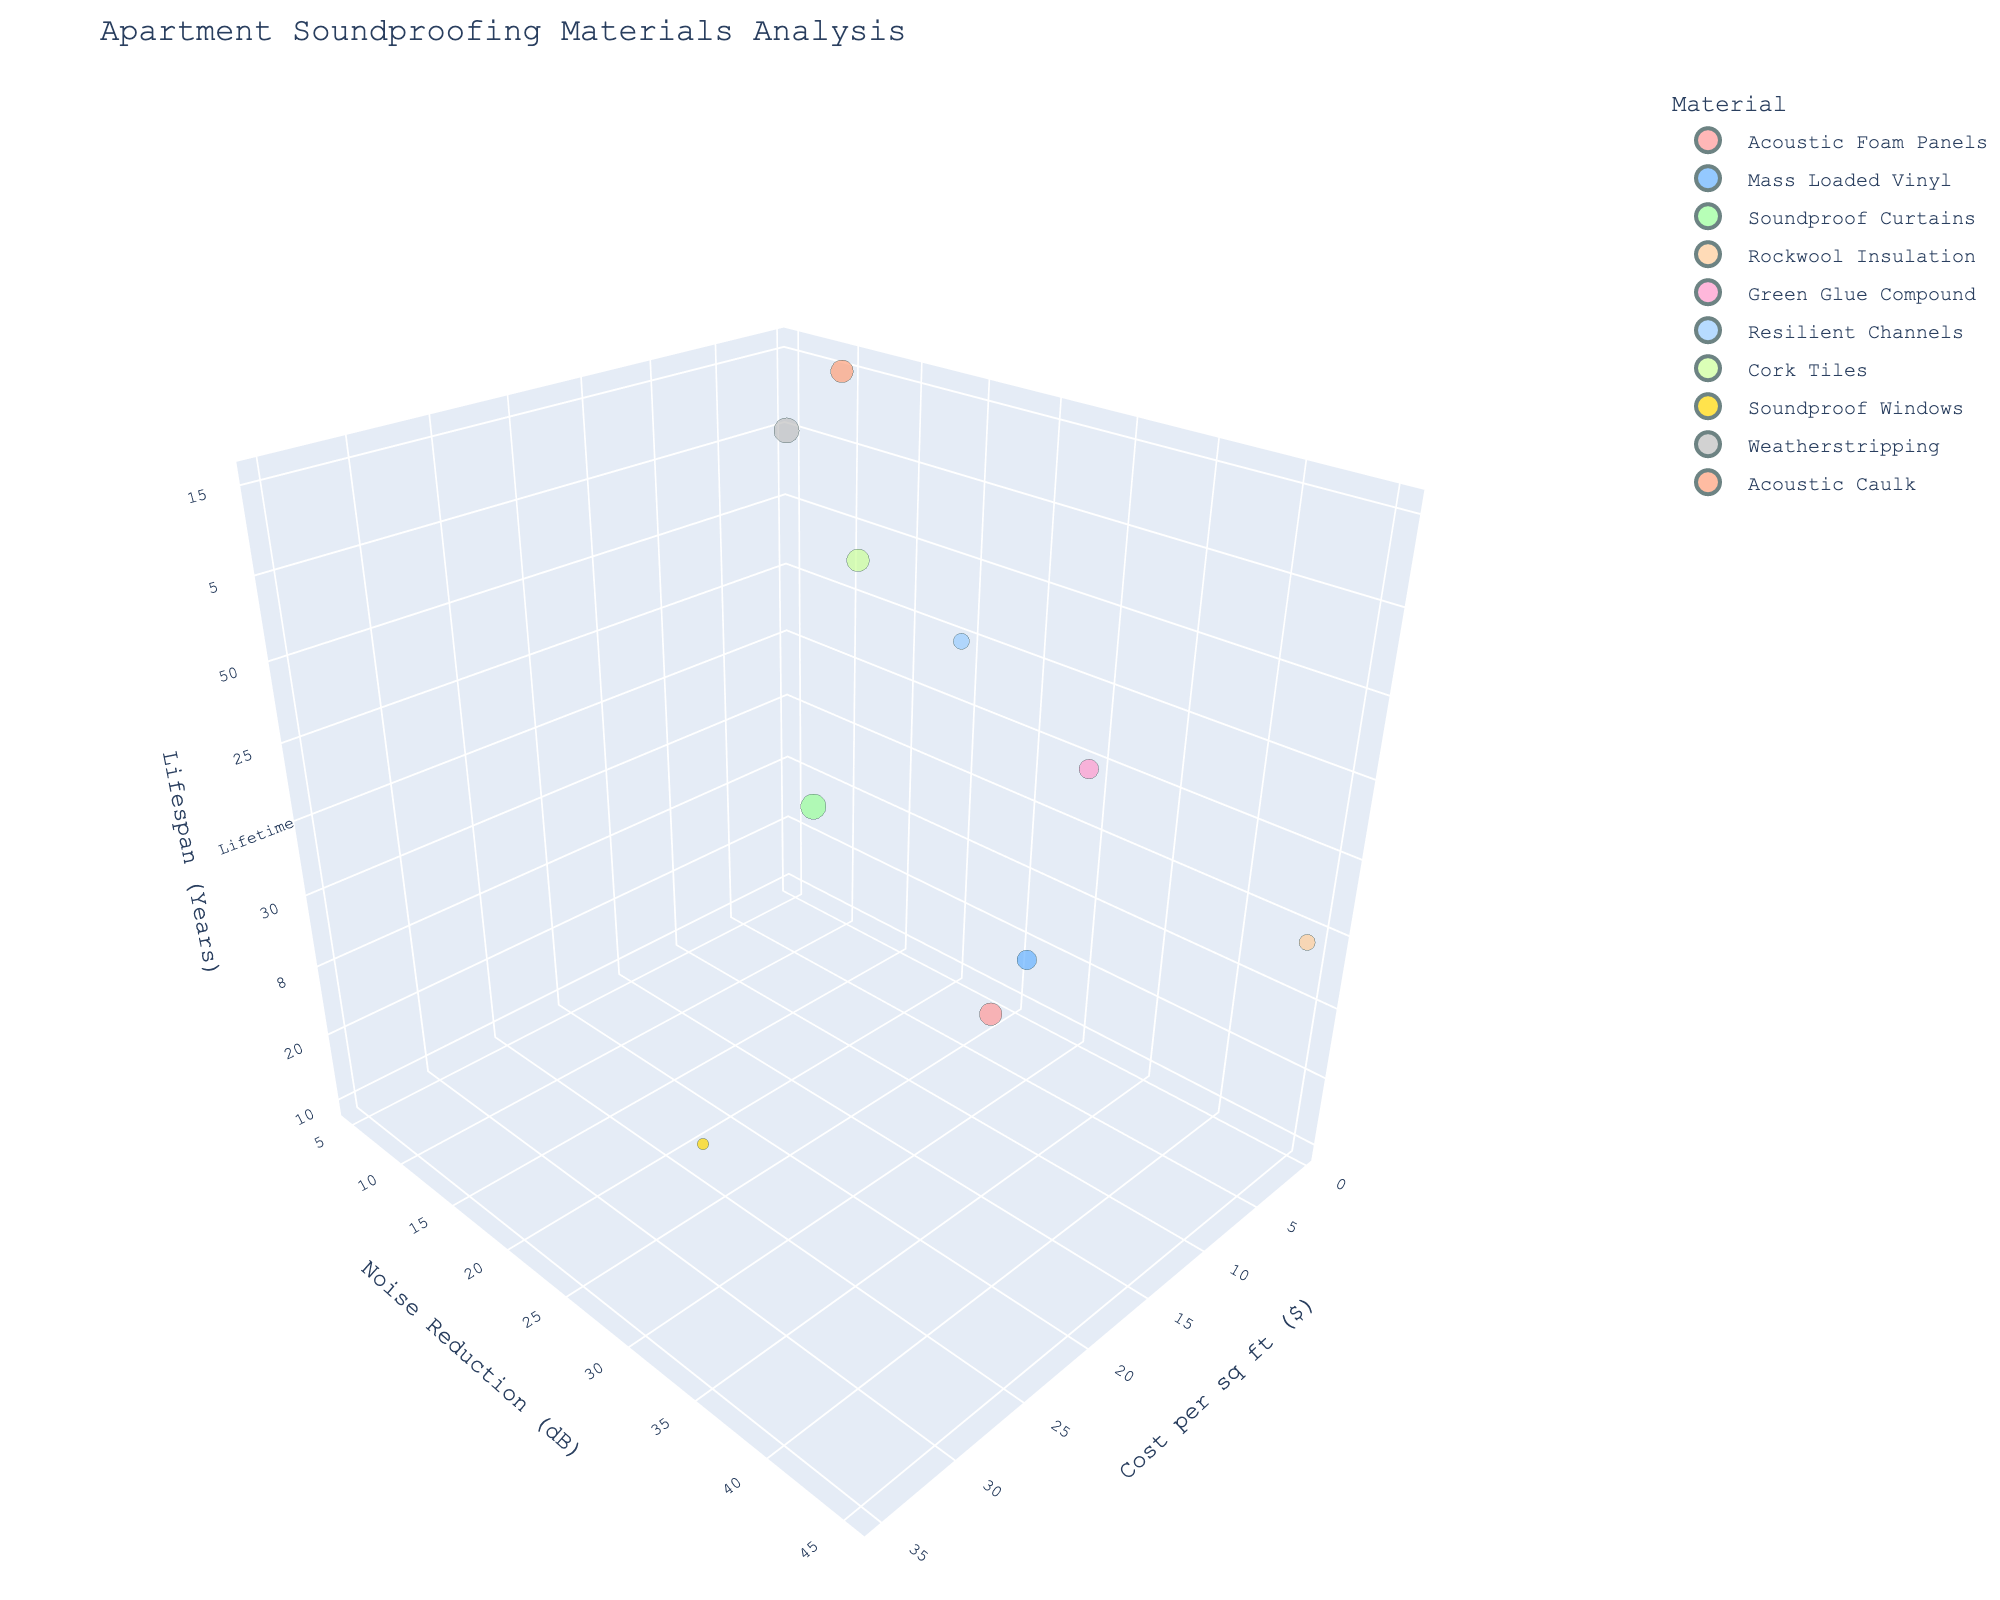What's the title of the chart? The title of the chart is typically displayed at the top of the figure.
Answer: Apartment Soundproofing Materials Analysis How many different materials are compared in the chart? By counting the number of unique colored bubbles, we can determine the number of materials represented.
Answer: 10 Which material is the most effective in noise reduction? By looking at the y-axis (Noise Reduction dB) and identifying the bubble that is highest on this axis, we can see which material has the highest noise reduction.
Answer: Rockwool Insulation Which material has the highest cost per square foot? By looking at the x-axis (Cost per sq ft) and identifying the bubble that is farthest to the right, we can find the material with the highest cost.
Answer: Soundproof Windows What is the lifespan of Acoustic Foam Panels? By locating the bubble representing Acoustic Foam Panels and checking its position along the z-axis (Lifespan Years), we can find the lifespan.
Answer: 10 years Which material has the longest lifespan? By looking at the z-axis (Lifespan Years) and identifying the bubble highest on this axis, we can determine the material with the longest lifespan.
Answer: Cork Tiles What's the average noise reduction and lifespan of Mass Loaded Vinyl and Soundproof Curtains? Find the Noise Reduction dB and Lifespan Years for both materials, sum them and divide each sum by 2. Noise Reduction for Mass Loaded Vinyl (27) and Soundproof Curtains (10): (27+10)/2 = 18.5. Lifespan for Mass Loaded Vinyl (20) and Soundproof Curtains (8): (20+8)/2 = 14.
Answer: 18.5 dB, 14 years Which material offers a balance of low cost and high noise reduction? Identify materials on the lower end of the x-axis (low cost) and the higher end of the y-axis (high noise reduction). Look for the best compromise between these two traits.
Answer: Mass Loaded Vinyl Is there a material that is both easy to install and effective in noise reduction? Check the bubbles with larger sizes (indicating higher ease of installation) and high positions along the y-axis (indicating high noise reduction).
Answer: Acoustic Foam Panels Which material shows a lifetime guarantee? By looking at the z-axis for Lifespan Years and identifying any bubble with 'Lifetime' as its lifespan, we find the material guaranteed for life.
Answer: Green Glue Compound 